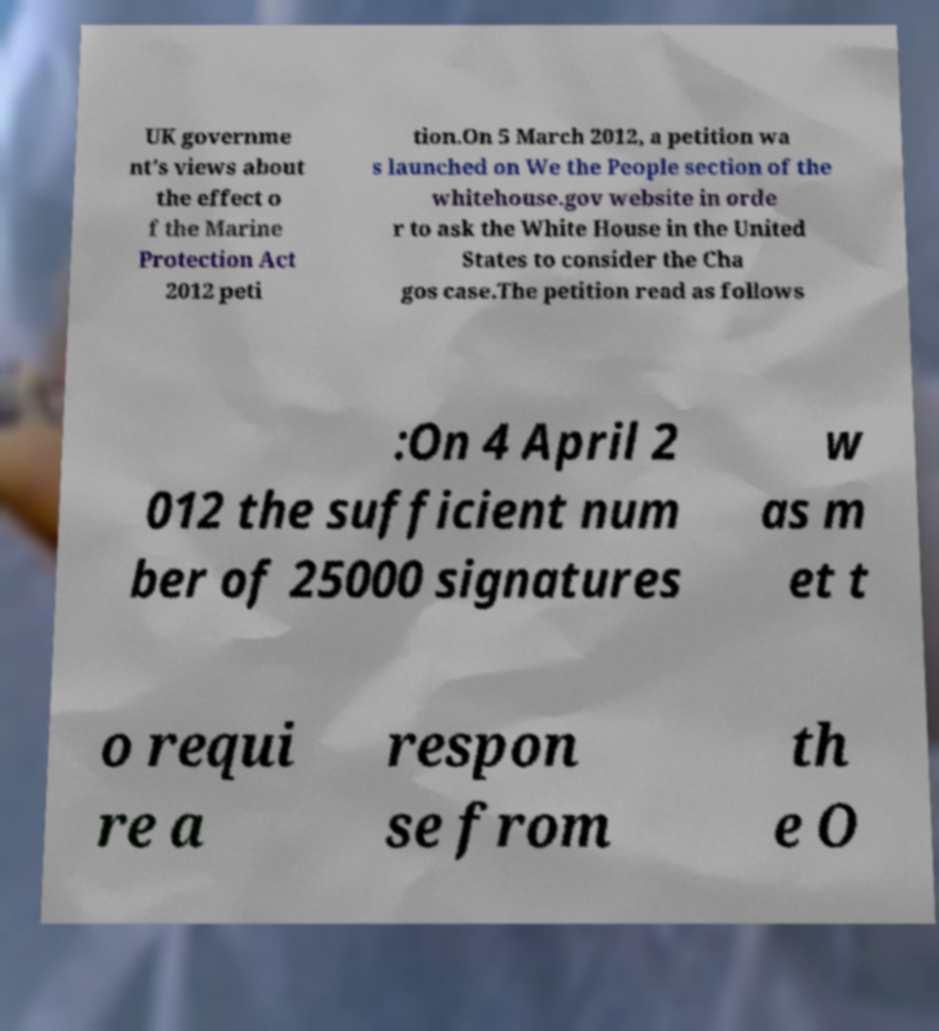I need the written content from this picture converted into text. Can you do that? UK governme nt's views about the effect o f the Marine Protection Act 2012 peti tion.On 5 March 2012, a petition wa s launched on We the People section of the whitehouse.gov website in orde r to ask the White House in the United States to consider the Cha gos case.The petition read as follows :On 4 April 2 012 the sufficient num ber of 25000 signatures w as m et t o requi re a respon se from th e O 